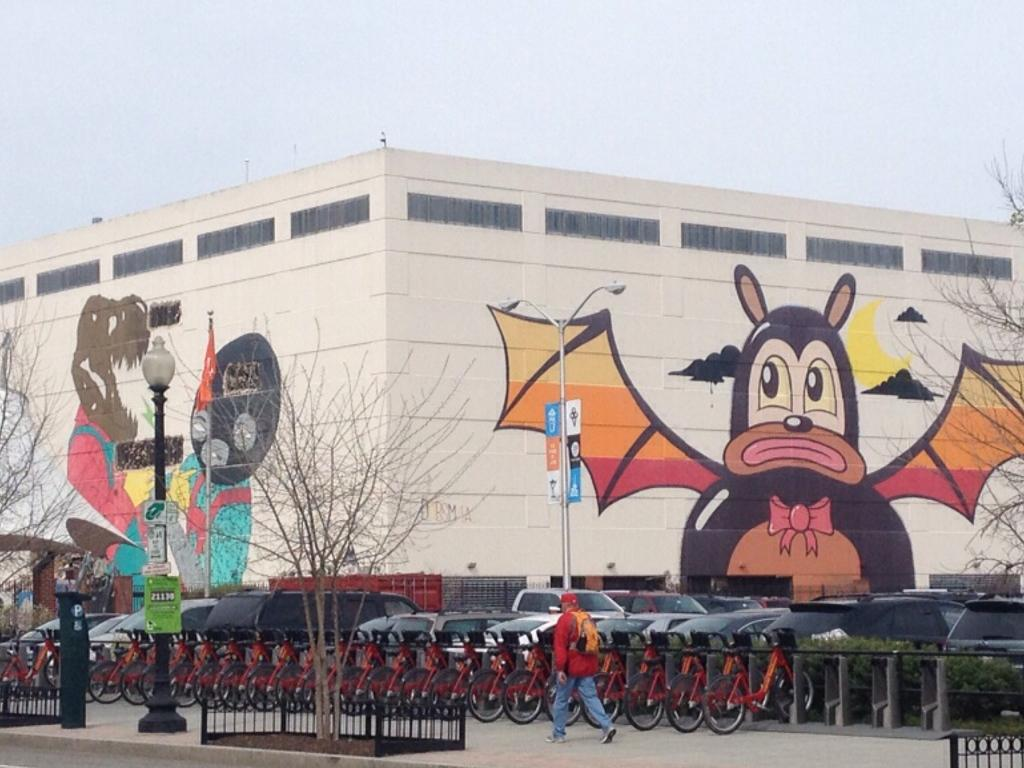What type of structure is in the image? There is a building in the image. What decorative elements are on the building? There are paintings on the building. Who or what else can be seen in the image? There are people and bicycles visible in the image. What mode of transportation is also present in the image? Cars are present in the image. What type of barrier is in the image? There is a fencing in the image. Where are the cherries placed on the cushion in the image? There are no cherries or cushions present in the image. 